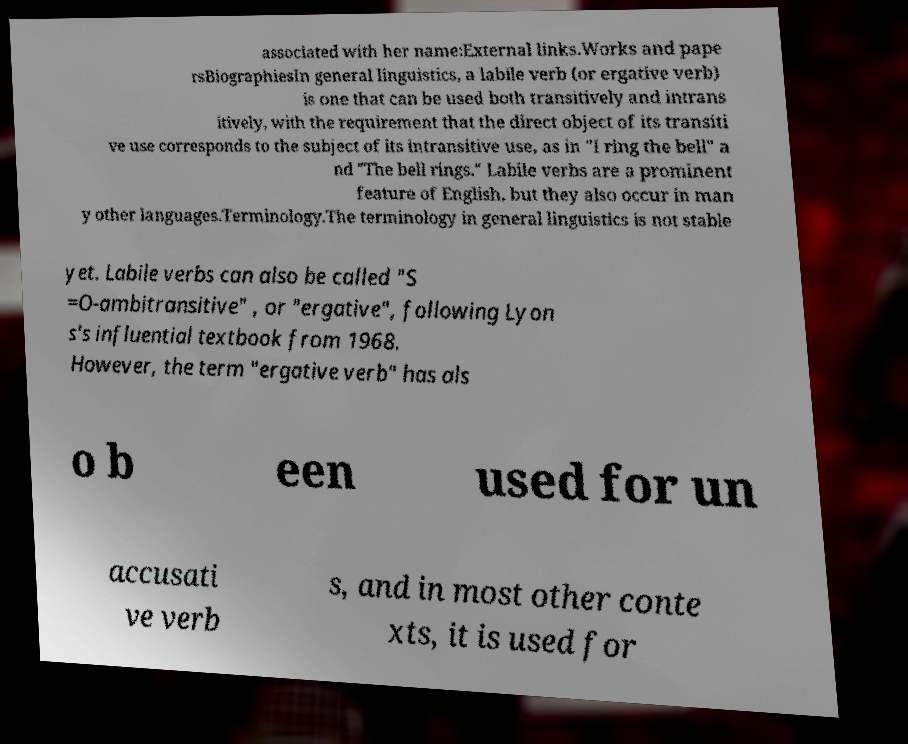There's text embedded in this image that I need extracted. Can you transcribe it verbatim? associated with her name:External links.Works and pape rsBiographiesIn general linguistics, a labile verb (or ergative verb) is one that can be used both transitively and intrans itively, with the requirement that the direct object of its transiti ve use corresponds to the subject of its intransitive use, as in "I ring the bell" a nd "The bell rings." Labile verbs are a prominent feature of English, but they also occur in man y other languages.Terminology.The terminology in general linguistics is not stable yet. Labile verbs can also be called "S =O-ambitransitive" , or "ergative", following Lyon s's influential textbook from 1968. However, the term "ergative verb" has als o b een used for un accusati ve verb s, and in most other conte xts, it is used for 